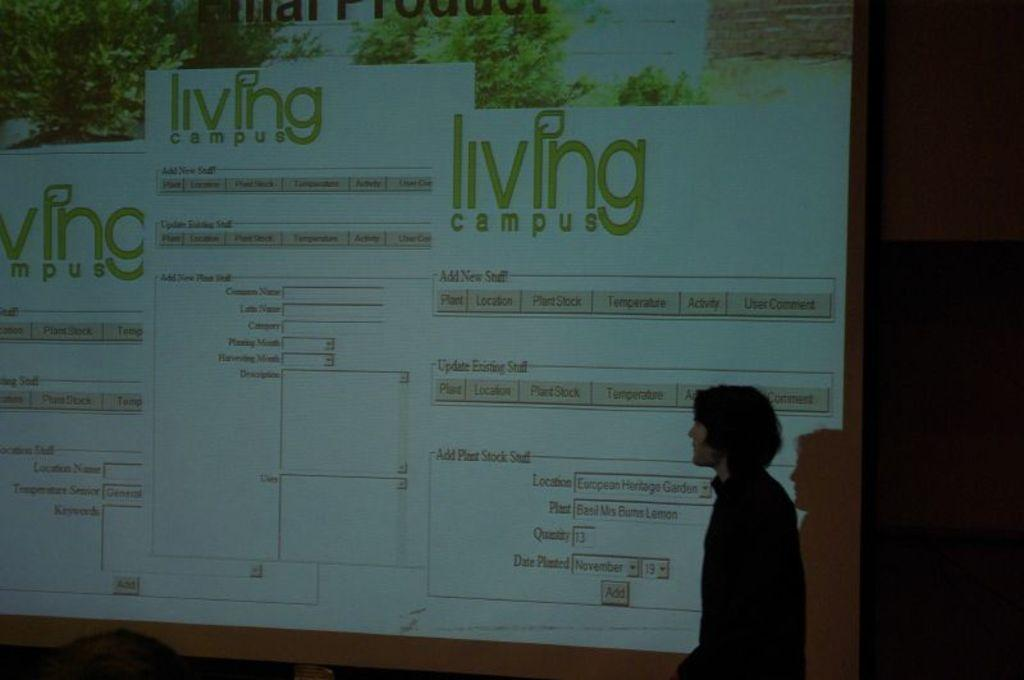<image>
Share a concise interpretation of the image provided. A screen displaying the name living campus a few times 